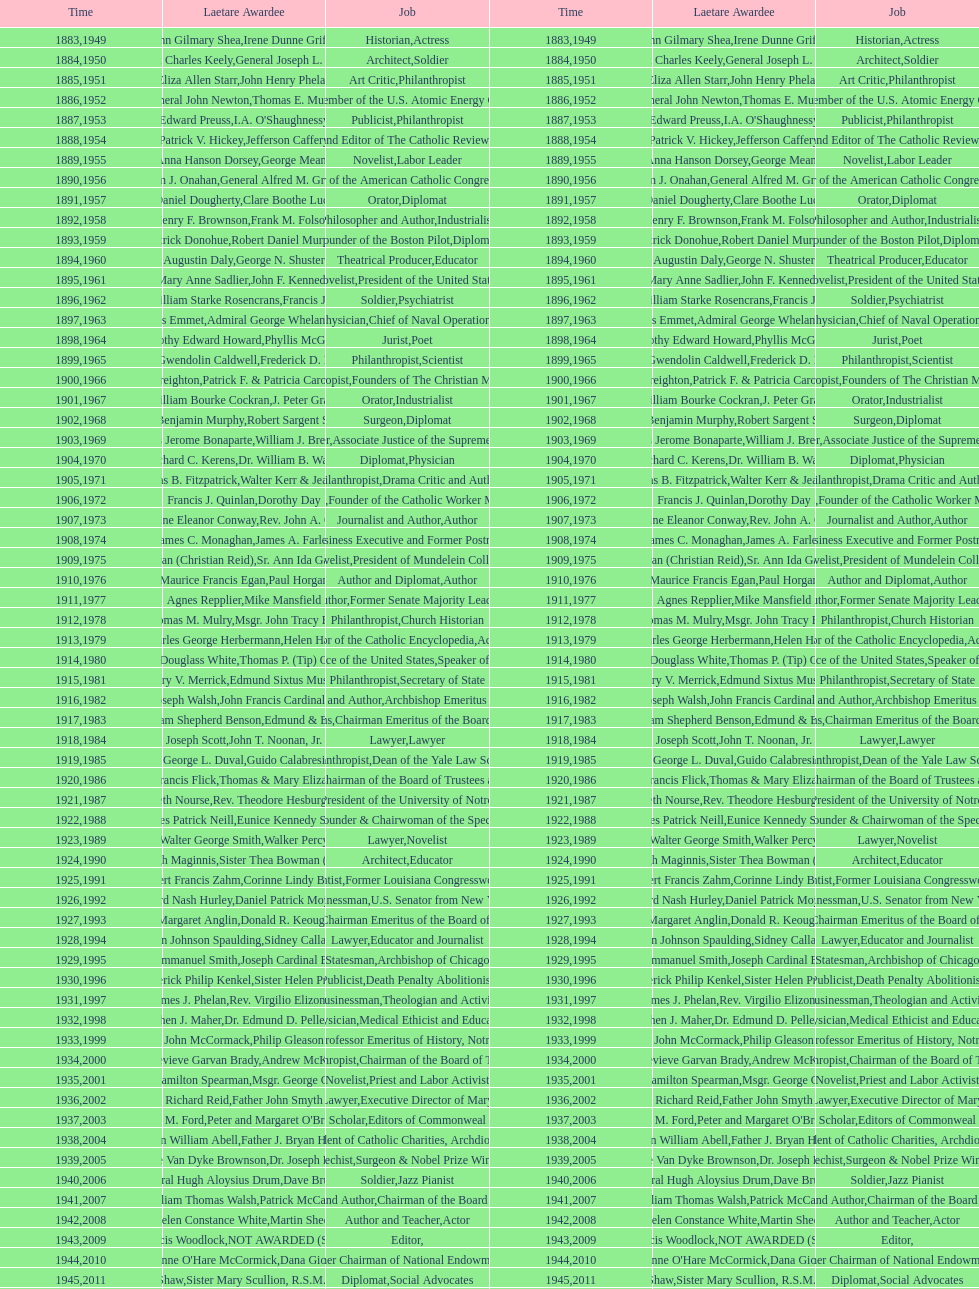How many laetare medalists were philantrohpists? 2. 